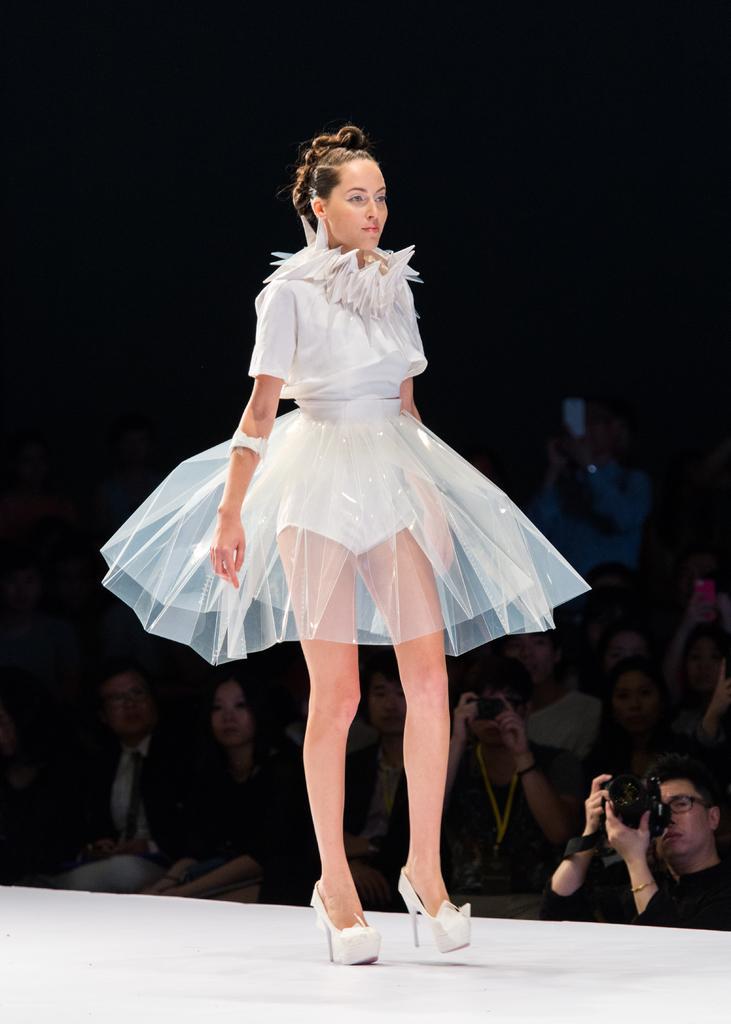Could you give a brief overview of what you see in this image? In this picture there is a woman who is wearing white dress and shoes. She is doing ramp-walking. In the back I can see many people who are sitting on the chair. In the bottom right corner there is a man who is holding a camera. 